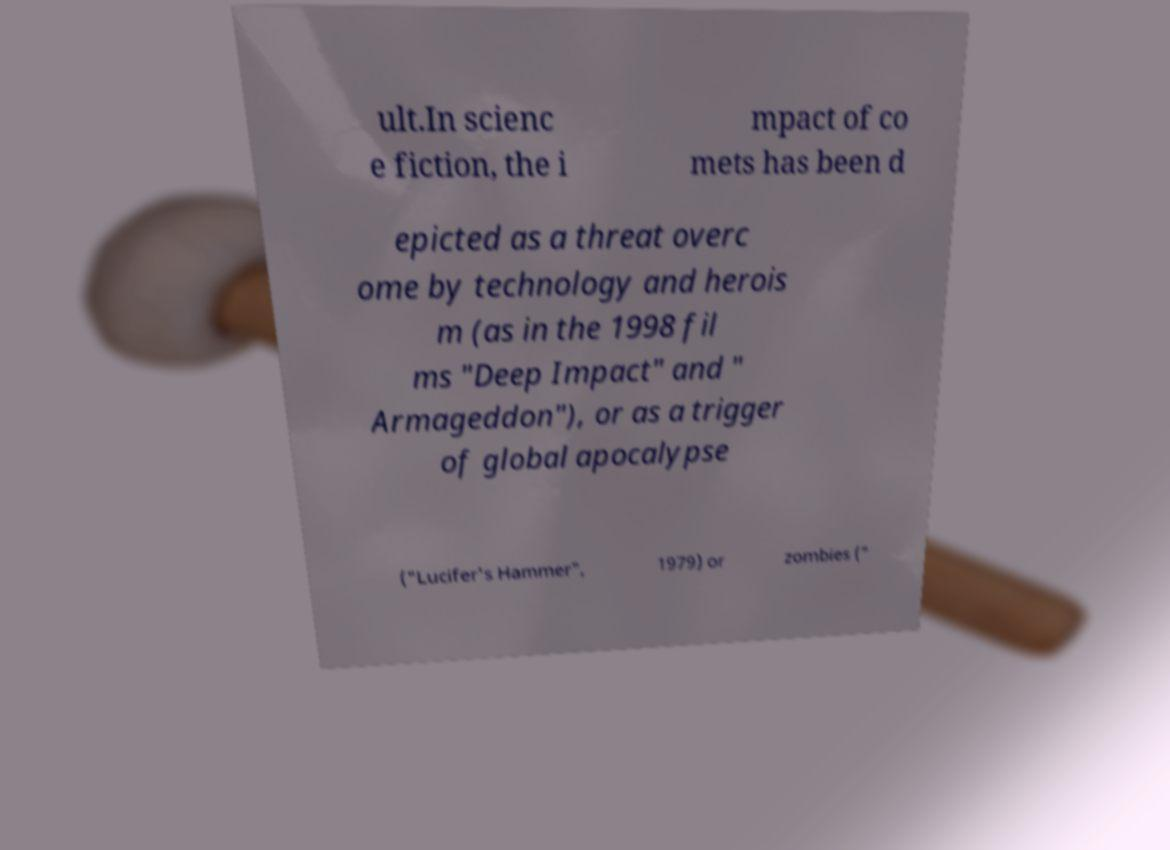For documentation purposes, I need the text within this image transcribed. Could you provide that? ult.In scienc e fiction, the i mpact of co mets has been d epicted as a threat overc ome by technology and herois m (as in the 1998 fil ms "Deep Impact" and " Armageddon"), or as a trigger of global apocalypse ("Lucifer's Hammer", 1979) or zombies (" 